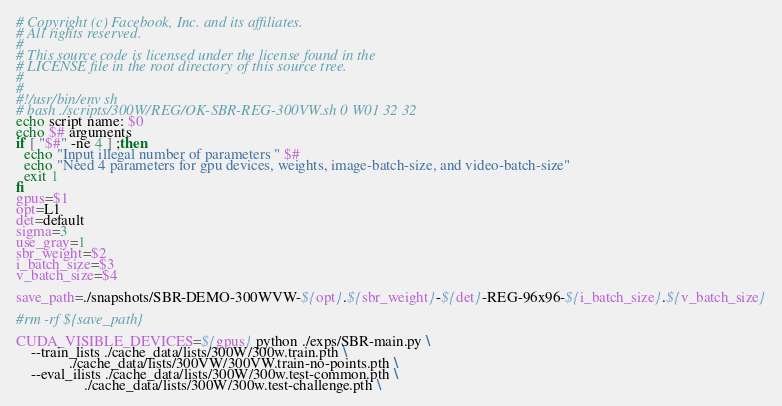Convert code to text. <code><loc_0><loc_0><loc_500><loc_500><_Bash_># Copyright (c) Facebook, Inc. and its affiliates.
# All rights reserved.
#
# This source code is licensed under the license found in the
# LICENSE file in the root directory of this source tree.
#
#
#!/usr/bin/env sh
# bash ./scripts/300W/REG/OK-SBR-REG-300VW.sh 0 W01 32 32
echo script name: $0
echo $# arguments
if [ "$#" -ne 4 ] ;then
  echo "Input illegal number of parameters " $#
  echo "Need 4 parameters for gpu devices, weights, image-batch-size, and video-batch-size"
  exit 1
fi
gpus=$1
opt=L1
det=default
sigma=3
use_gray=1
sbr_weight=$2
i_batch_size=$3
v_batch_size=$4

save_path=./snapshots/SBR-DEMO-300WVW-${opt}.${sbr_weight}-${det}-REG-96x96-${i_batch_size}.${v_batch_size}

#rm -rf ${save_path}

CUDA_VISIBLE_DEVICES=${gpus} python ./exps/SBR-main.py \
    --train_lists ./cache_data/lists/300W/300w.train.pth \
     		  ./cache_data/lists/300VW/300VW.train-no-points.pth \
    --eval_ilists ./cache_data/lists/300W/300w.test-common.pth \
                  ./cache_data/lists/300W/300w.test-challenge.pth \</code> 